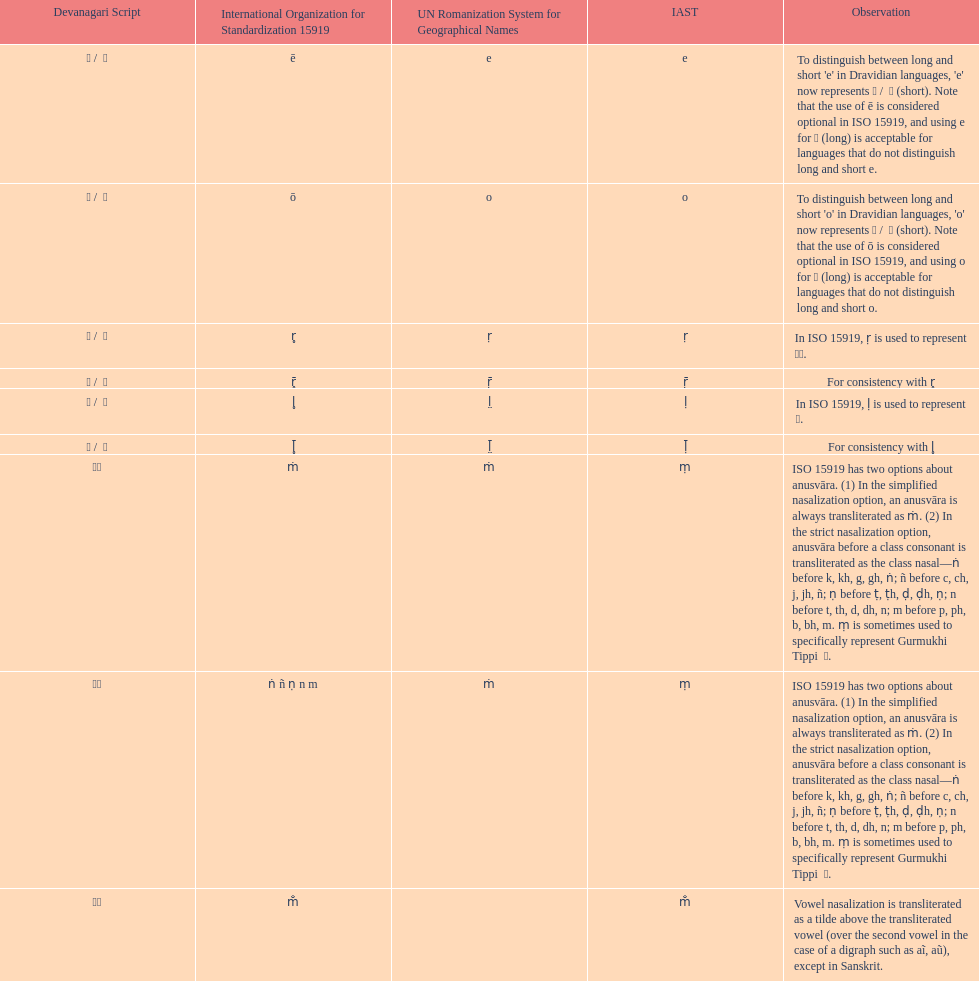What is listed previous to in iso 15919, &#7735; is used to represent &#2355;. under comments? For consistency with r̥. 